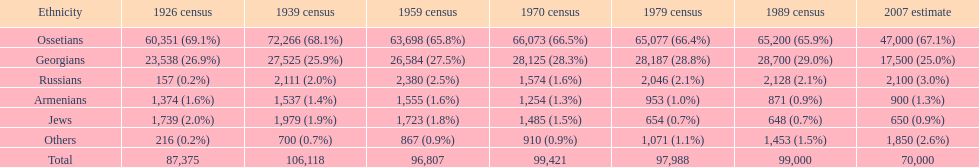How many ethnicities were below 1,000 people in 2007? 2. 